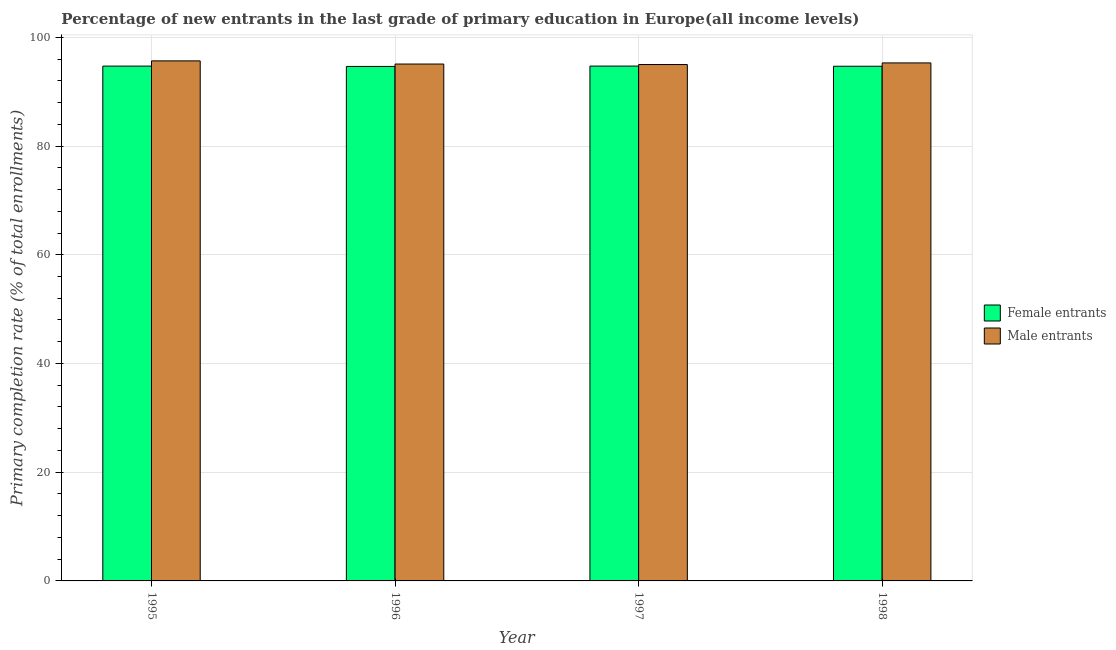How many different coloured bars are there?
Provide a short and direct response. 2. How many groups of bars are there?
Your answer should be compact. 4. In how many cases, is the number of bars for a given year not equal to the number of legend labels?
Your answer should be very brief. 0. What is the primary completion rate of female entrants in 1996?
Your response must be concise. 94.64. Across all years, what is the maximum primary completion rate of male entrants?
Keep it short and to the point. 95.66. Across all years, what is the minimum primary completion rate of male entrants?
Offer a very short reply. 94.99. In which year was the primary completion rate of male entrants minimum?
Your response must be concise. 1997. What is the total primary completion rate of female entrants in the graph?
Make the answer very short. 378.73. What is the difference between the primary completion rate of female entrants in 1995 and that in 1998?
Make the answer very short. 0.03. What is the difference between the primary completion rate of male entrants in 1998 and the primary completion rate of female entrants in 1996?
Make the answer very short. 0.21. What is the average primary completion rate of female entrants per year?
Provide a succinct answer. 94.68. What is the ratio of the primary completion rate of female entrants in 1995 to that in 1997?
Your response must be concise. 1. Is the primary completion rate of male entrants in 1997 less than that in 1998?
Offer a terse response. Yes. What is the difference between the highest and the second highest primary completion rate of male entrants?
Your answer should be very brief. 0.38. What is the difference between the highest and the lowest primary completion rate of female entrants?
Offer a terse response. 0.06. In how many years, is the primary completion rate of female entrants greater than the average primary completion rate of female entrants taken over all years?
Offer a very short reply. 2. Is the sum of the primary completion rate of female entrants in 1996 and 1998 greater than the maximum primary completion rate of male entrants across all years?
Give a very brief answer. Yes. What does the 1st bar from the left in 1996 represents?
Your response must be concise. Female entrants. What does the 2nd bar from the right in 1997 represents?
Provide a succinct answer. Female entrants. Are all the bars in the graph horizontal?
Your response must be concise. No. Are the values on the major ticks of Y-axis written in scientific E-notation?
Your response must be concise. No. Where does the legend appear in the graph?
Provide a short and direct response. Center right. How are the legend labels stacked?
Give a very brief answer. Vertical. What is the title of the graph?
Offer a very short reply. Percentage of new entrants in the last grade of primary education in Europe(all income levels). What is the label or title of the X-axis?
Your answer should be very brief. Year. What is the label or title of the Y-axis?
Offer a terse response. Primary completion rate (% of total enrollments). What is the Primary completion rate (% of total enrollments) in Female entrants in 1995?
Give a very brief answer. 94.7. What is the Primary completion rate (% of total enrollments) in Male entrants in 1995?
Provide a short and direct response. 95.66. What is the Primary completion rate (% of total enrollments) in Female entrants in 1996?
Give a very brief answer. 94.64. What is the Primary completion rate (% of total enrollments) of Male entrants in 1996?
Make the answer very short. 95.08. What is the Primary completion rate (% of total enrollments) of Female entrants in 1997?
Provide a short and direct response. 94.71. What is the Primary completion rate (% of total enrollments) in Male entrants in 1997?
Provide a succinct answer. 94.99. What is the Primary completion rate (% of total enrollments) of Female entrants in 1998?
Ensure brevity in your answer.  94.68. What is the Primary completion rate (% of total enrollments) of Male entrants in 1998?
Offer a terse response. 95.29. Across all years, what is the maximum Primary completion rate (% of total enrollments) of Female entrants?
Keep it short and to the point. 94.71. Across all years, what is the maximum Primary completion rate (% of total enrollments) in Male entrants?
Your response must be concise. 95.66. Across all years, what is the minimum Primary completion rate (% of total enrollments) in Female entrants?
Your response must be concise. 94.64. Across all years, what is the minimum Primary completion rate (% of total enrollments) in Male entrants?
Your response must be concise. 94.99. What is the total Primary completion rate (% of total enrollments) of Female entrants in the graph?
Ensure brevity in your answer.  378.73. What is the total Primary completion rate (% of total enrollments) of Male entrants in the graph?
Offer a terse response. 381.03. What is the difference between the Primary completion rate (% of total enrollments) in Female entrants in 1995 and that in 1996?
Offer a very short reply. 0.06. What is the difference between the Primary completion rate (% of total enrollments) of Male entrants in 1995 and that in 1996?
Your answer should be very brief. 0.58. What is the difference between the Primary completion rate (% of total enrollments) in Female entrants in 1995 and that in 1997?
Provide a short and direct response. -0. What is the difference between the Primary completion rate (% of total enrollments) of Male entrants in 1995 and that in 1997?
Your response must be concise. 0.67. What is the difference between the Primary completion rate (% of total enrollments) in Female entrants in 1995 and that in 1998?
Give a very brief answer. 0.03. What is the difference between the Primary completion rate (% of total enrollments) in Male entrants in 1995 and that in 1998?
Provide a succinct answer. 0.38. What is the difference between the Primary completion rate (% of total enrollments) of Female entrants in 1996 and that in 1997?
Give a very brief answer. -0.06. What is the difference between the Primary completion rate (% of total enrollments) of Male entrants in 1996 and that in 1997?
Ensure brevity in your answer.  0.09. What is the difference between the Primary completion rate (% of total enrollments) of Female entrants in 1996 and that in 1998?
Keep it short and to the point. -0.03. What is the difference between the Primary completion rate (% of total enrollments) of Male entrants in 1996 and that in 1998?
Provide a succinct answer. -0.21. What is the difference between the Primary completion rate (% of total enrollments) of Female entrants in 1997 and that in 1998?
Your answer should be very brief. 0.03. What is the difference between the Primary completion rate (% of total enrollments) of Male entrants in 1997 and that in 1998?
Keep it short and to the point. -0.3. What is the difference between the Primary completion rate (% of total enrollments) of Female entrants in 1995 and the Primary completion rate (% of total enrollments) of Male entrants in 1996?
Make the answer very short. -0.38. What is the difference between the Primary completion rate (% of total enrollments) in Female entrants in 1995 and the Primary completion rate (% of total enrollments) in Male entrants in 1997?
Offer a very short reply. -0.29. What is the difference between the Primary completion rate (% of total enrollments) of Female entrants in 1995 and the Primary completion rate (% of total enrollments) of Male entrants in 1998?
Your response must be concise. -0.58. What is the difference between the Primary completion rate (% of total enrollments) of Female entrants in 1996 and the Primary completion rate (% of total enrollments) of Male entrants in 1997?
Offer a very short reply. -0.35. What is the difference between the Primary completion rate (% of total enrollments) in Female entrants in 1996 and the Primary completion rate (% of total enrollments) in Male entrants in 1998?
Your answer should be compact. -0.65. What is the difference between the Primary completion rate (% of total enrollments) in Female entrants in 1997 and the Primary completion rate (% of total enrollments) in Male entrants in 1998?
Keep it short and to the point. -0.58. What is the average Primary completion rate (% of total enrollments) of Female entrants per year?
Your answer should be very brief. 94.68. What is the average Primary completion rate (% of total enrollments) in Male entrants per year?
Keep it short and to the point. 95.26. In the year 1995, what is the difference between the Primary completion rate (% of total enrollments) in Female entrants and Primary completion rate (% of total enrollments) in Male entrants?
Offer a very short reply. -0.96. In the year 1996, what is the difference between the Primary completion rate (% of total enrollments) in Female entrants and Primary completion rate (% of total enrollments) in Male entrants?
Give a very brief answer. -0.44. In the year 1997, what is the difference between the Primary completion rate (% of total enrollments) of Female entrants and Primary completion rate (% of total enrollments) of Male entrants?
Offer a very short reply. -0.28. In the year 1998, what is the difference between the Primary completion rate (% of total enrollments) of Female entrants and Primary completion rate (% of total enrollments) of Male entrants?
Offer a terse response. -0.61. What is the ratio of the Primary completion rate (% of total enrollments) in Female entrants in 1995 to that in 1996?
Keep it short and to the point. 1. What is the ratio of the Primary completion rate (% of total enrollments) in Male entrants in 1995 to that in 1997?
Provide a short and direct response. 1.01. What is the ratio of the Primary completion rate (% of total enrollments) in Male entrants in 1995 to that in 1998?
Provide a succinct answer. 1. What is the ratio of the Primary completion rate (% of total enrollments) of Male entrants in 1996 to that in 1997?
Provide a short and direct response. 1. What is the ratio of the Primary completion rate (% of total enrollments) in Female entrants in 1997 to that in 1998?
Offer a terse response. 1. What is the difference between the highest and the second highest Primary completion rate (% of total enrollments) of Female entrants?
Your answer should be very brief. 0. What is the difference between the highest and the second highest Primary completion rate (% of total enrollments) in Male entrants?
Ensure brevity in your answer.  0.38. What is the difference between the highest and the lowest Primary completion rate (% of total enrollments) of Female entrants?
Provide a short and direct response. 0.06. What is the difference between the highest and the lowest Primary completion rate (% of total enrollments) of Male entrants?
Your answer should be compact. 0.67. 